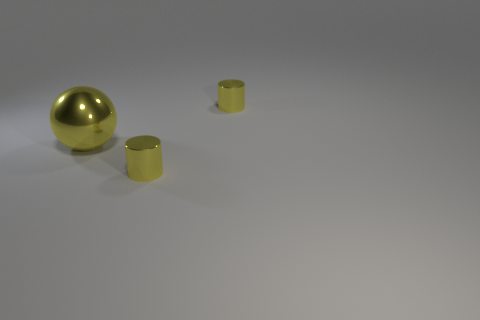Add 3 tiny shiny cylinders. How many objects exist? 6 Subtract all purple cylinders. How many blue spheres are left? 0 Subtract all small metallic things. Subtract all big yellow metallic things. How many objects are left? 0 Add 1 big yellow shiny things. How many big yellow shiny things are left? 2 Add 1 big yellow objects. How many big yellow objects exist? 2 Subtract 0 blue cylinders. How many objects are left? 3 Subtract all cylinders. How many objects are left? 1 Subtract all cyan balls. Subtract all cyan cubes. How many balls are left? 1 